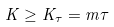<formula> <loc_0><loc_0><loc_500><loc_500>K \geq K _ { \tau } = m \tau</formula> 